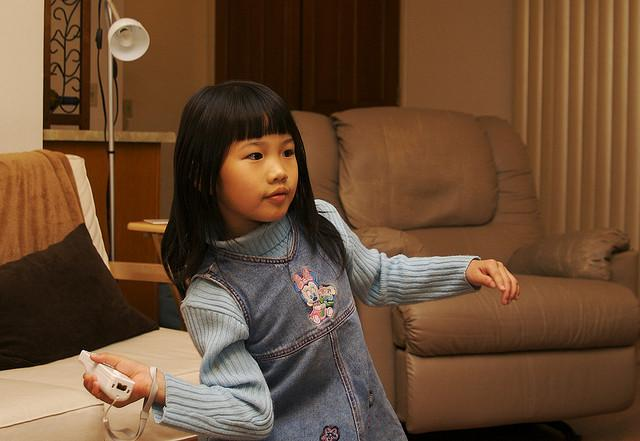Who created the character on the girls dress? Please explain your reasoning. walt disney. Walt disney created minnie mouse. 